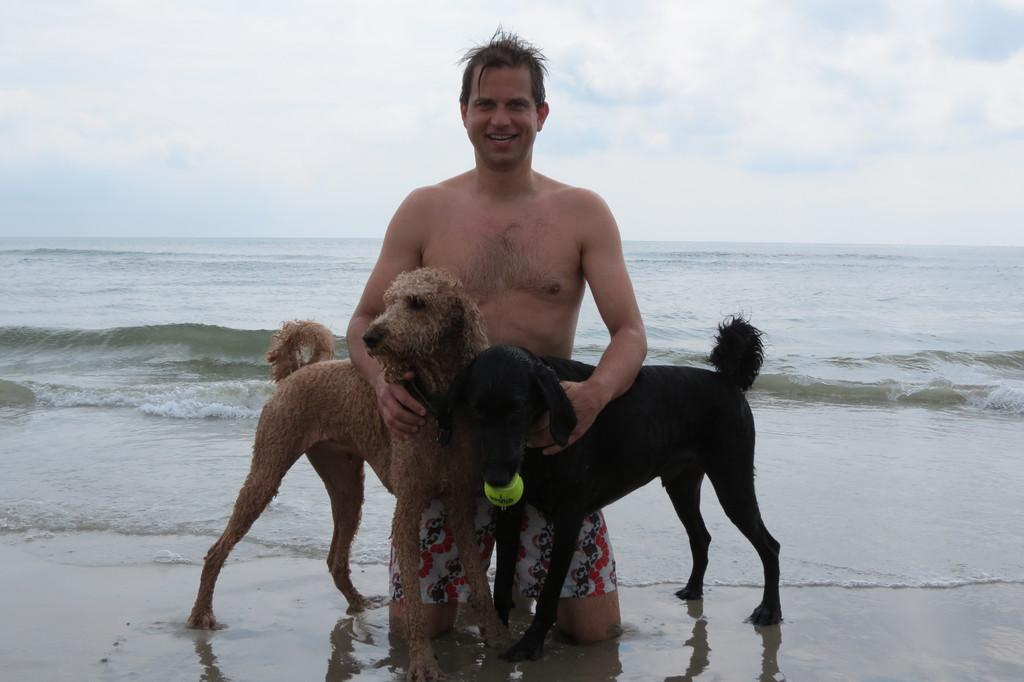Who is present in the image? There is a man in the image. What animals are in the image? There are two dogs in the image. What can be seen in the background of the image? Water is visible in the background of the image. What is visible at the top of the image? The sky is visible at the top of the image. What type of cabbage is being harvested on the farm in the image? There is no farm or cabbage present in the image; it features a man and two dogs with water and sky visible in the background. 